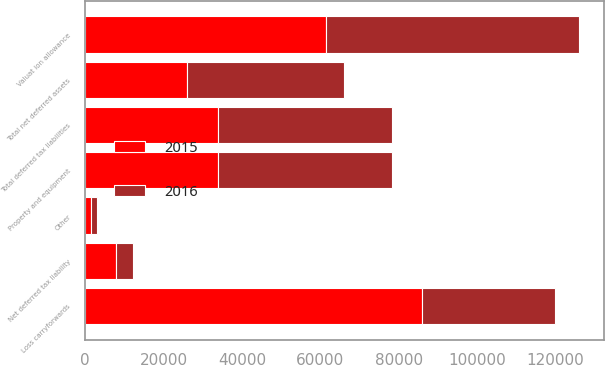Convert chart. <chart><loc_0><loc_0><loc_500><loc_500><stacked_bar_chart><ecel><fcel>Loss carryforwards<fcel>Other<fcel>Valuat ion allowance<fcel>Total net deferred assets<fcel>Property and equipment<fcel>Total deferred tax liabilities<fcel>Net deferred tax liability<nl><fcel>2016<fcel>33862<fcel>1564<fcel>64573<fcel>40182<fcel>44398<fcel>44398<fcel>4216<nl><fcel>2015<fcel>85939<fcel>1460<fcel>61437<fcel>25962<fcel>33862<fcel>33862<fcel>7900<nl></chart> 